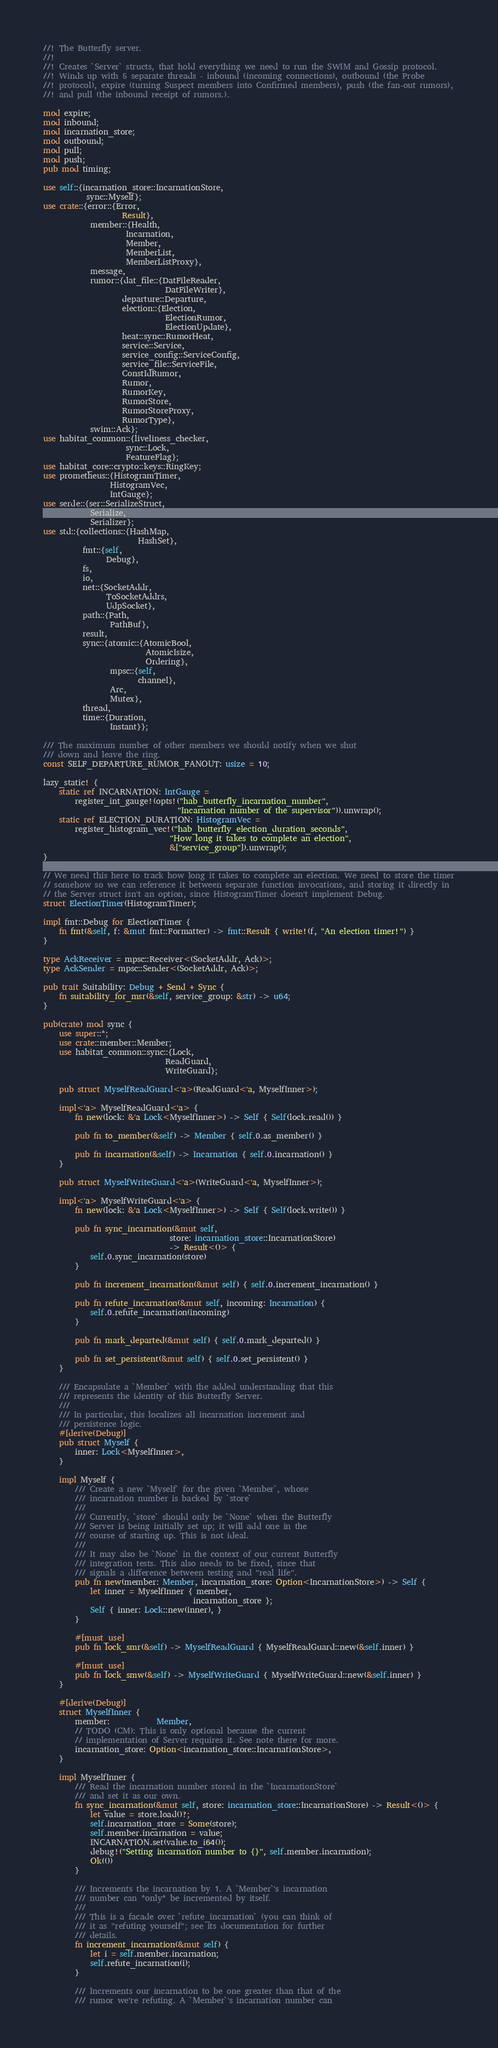<code> <loc_0><loc_0><loc_500><loc_500><_Rust_>//! The Butterfly server.
//!
//! Creates `Server` structs, that hold everything we need to run the SWIM and Gossip protocol.
//! Winds up with 5 separate threads - inbound (incoming connections), outbound (the Probe
//! protocol), expire (turning Suspect members into Confirmed members), push (the fan-out rumors),
//! and pull (the inbound receipt of rumors.).

mod expire;
mod inbound;
mod incarnation_store;
mod outbound;
mod pull;
mod push;
pub mod timing;

use self::{incarnation_store::IncarnationStore,
           sync::Myself};
use crate::{error::{Error,
                    Result},
            member::{Health,
                     Incarnation,
                     Member,
                     MemberList,
                     MemberListProxy},
            message,
            rumor::{dat_file::{DatFileReader,
                               DatFileWriter},
                    departure::Departure,
                    election::{Election,
                               ElectionRumor,
                               ElectionUpdate},
                    heat::sync::RumorHeat,
                    service::Service,
                    service_config::ServiceConfig,
                    service_file::ServiceFile,
                    ConstIdRumor,
                    Rumor,
                    RumorKey,
                    RumorStore,
                    RumorStoreProxy,
                    RumorType},
            swim::Ack};
use habitat_common::{liveliness_checker,
                     sync::Lock,
                     FeatureFlag};
use habitat_core::crypto::keys::RingKey;
use prometheus::{HistogramTimer,
                 HistogramVec,
                 IntGauge};
use serde::{ser::SerializeStruct,
            Serialize,
            Serializer};
use std::{collections::{HashMap,
                        HashSet},
          fmt::{self,
                Debug},
          fs,
          io,
          net::{SocketAddr,
                ToSocketAddrs,
                UdpSocket},
          path::{Path,
                 PathBuf},
          result,
          sync::{atomic::{AtomicBool,
                          AtomicIsize,
                          Ordering},
                 mpsc::{self,
                        channel},
                 Arc,
                 Mutex},
          thread,
          time::{Duration,
                 Instant}};

/// The maximum number of other members we should notify when we shut
/// down and leave the ring.
const SELF_DEPARTURE_RUMOR_FANOUT: usize = 10;

lazy_static! {
    static ref INCARNATION: IntGauge =
        register_int_gauge!(opts!("hab_butterfly_incarnation_number",
                                  "Incarnation number of the supervisor")).unwrap();
    static ref ELECTION_DURATION: HistogramVec =
        register_histogram_vec!("hab_butterfly_election_duration_seconds",
                                "How long it takes to complete an election",
                                &["service_group"]).unwrap();
}

// We need this here to track how long it takes to complete an election. We need to store the timer
// somehow so we can reference it between separate function invocations, and storing it directly in
// the Server struct isn't an option, since HistogramTimer doesn't implement Debug.
struct ElectionTimer(HistogramTimer);

impl fmt::Debug for ElectionTimer {
    fn fmt(&self, f: &mut fmt::Formatter) -> fmt::Result { write!(f, "An election timer!") }
}

type AckReceiver = mpsc::Receiver<(SocketAddr, Ack)>;
type AckSender = mpsc::Sender<(SocketAddr, Ack)>;

pub trait Suitability: Debug + Send + Sync {
    fn suitability_for_msr(&self, service_group: &str) -> u64;
}

pub(crate) mod sync {
    use super::*;
    use crate::member::Member;
    use habitat_common::sync::{Lock,
                               ReadGuard,
                               WriteGuard};

    pub struct MyselfReadGuard<'a>(ReadGuard<'a, MyselfInner>);

    impl<'a> MyselfReadGuard<'a> {
        fn new(lock: &'a Lock<MyselfInner>) -> Self { Self(lock.read()) }

        pub fn to_member(&self) -> Member { self.0.as_member() }

        pub fn incarnation(&self) -> Incarnation { self.0.incarnation() }
    }

    pub struct MyselfWriteGuard<'a>(WriteGuard<'a, MyselfInner>);

    impl<'a> MyselfWriteGuard<'a> {
        fn new(lock: &'a Lock<MyselfInner>) -> Self { Self(lock.write()) }

        pub fn sync_incarnation(&mut self,
                                store: incarnation_store::IncarnationStore)
                                -> Result<()> {
            self.0.sync_incarnation(store)
        }

        pub fn increment_incarnation(&mut self) { self.0.increment_incarnation() }

        pub fn refute_incarnation(&mut self, incoming: Incarnation) {
            self.0.refute_incarnation(incoming)
        }

        pub fn mark_departed(&mut self) { self.0.mark_departed() }

        pub fn set_persistent(&mut self) { self.0.set_persistent() }
    }

    /// Encapsulate a `Member` with the added understanding that this
    /// represents the identity of this Butterfly Server.
    ///
    /// In particular, this localizes all incarnation increment and
    /// persistence logic.
    #[derive(Debug)]
    pub struct Myself {
        inner: Lock<MyselfInner>,
    }

    impl Myself {
        /// Create a new `Myself` for the given `Member`, whose
        /// incarnation number is backed by `store`
        ///
        /// Currently, `store` should only be `None` when the Butterfly
        /// Server is being initially set up; it will add one in the
        /// course of starting up. This is not ideal.
        ///
        /// It may also be `None` in the context of our current Butterfly
        /// integration tests. This also needs to be fixed, since that
        /// signals a difference between testing and "real life".
        pub fn new(member: Member, incarnation_store: Option<IncarnationStore>) -> Self {
            let inner = MyselfInner { member,
                                      incarnation_store };
            Self { inner: Lock::new(inner), }
        }

        #[must_use]
        pub fn lock_smr(&self) -> MyselfReadGuard { MyselfReadGuard::new(&self.inner) }

        #[must_use]
        pub fn lock_smw(&self) -> MyselfWriteGuard { MyselfWriteGuard::new(&self.inner) }
    }

    #[derive(Debug)]
    struct MyselfInner {
        member:            Member,
        // TODO (CM): This is only optional because the current
        // implementation of Server requires it. See note there for more.
        incarnation_store: Option<incarnation_store::IncarnationStore>,
    }

    impl MyselfInner {
        /// Read the incarnation number stored in the `IncarnationStore`
        /// and set it as our own.
        fn sync_incarnation(&mut self, store: incarnation_store::IncarnationStore) -> Result<()> {
            let value = store.load()?;
            self.incarnation_store = Some(store);
            self.member.incarnation = value;
            INCARNATION.set(value.to_i64());
            debug!("Setting incarnation number to {}", self.member.incarnation);
            Ok(())
        }

        /// Increments the incarnation by 1. A `Member`'s incarnation
        /// number can *only* be incremented by itself.
        ///
        /// This is a facade over `refute_incarnation` (you can think of
        /// it as "refuting yourself"; see its documentation for further
        /// details.
        fn increment_incarnation(&mut self) {
            let i = self.member.incarnation;
            self.refute_incarnation(i);
        }

        /// Increments our incarnation to be one greater than that of the
        /// rumor we're refuting. A `Member`'s incarnation number can</code> 